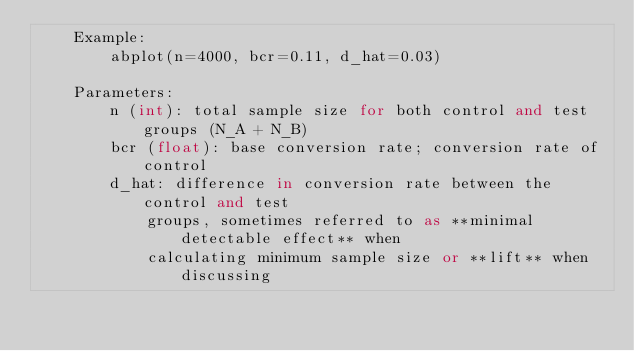<code> <loc_0><loc_0><loc_500><loc_500><_Python_>    Example:
        abplot(n=4000, bcr=0.11, d_hat=0.03)

    Parameters:
        n (int): total sample size for both control and test groups (N_A + N_B)
        bcr (float): base conversion rate; conversion rate of control
        d_hat: difference in conversion rate between the control and test
            groups, sometimes referred to as **minimal detectable effect** when
            calculating minimum sample size or **lift** when discussing</code> 